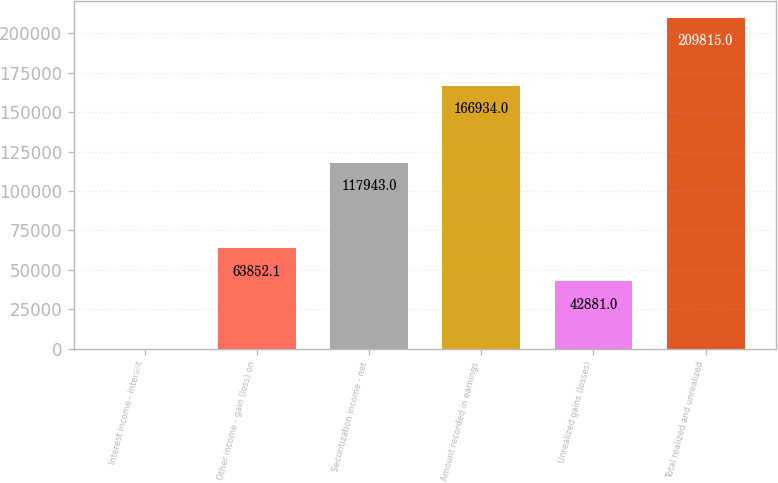<chart> <loc_0><loc_0><loc_500><loc_500><bar_chart><fcel>Interest income - interest<fcel>Other income - gain (loss) on<fcel>Securitization income - net<fcel>Amount recorded in earnings<fcel>Unrealized gains (losses)<fcel>Total realized and unrealized<nl><fcel>104<fcel>63852.1<fcel>117943<fcel>166934<fcel>42881<fcel>209815<nl></chart> 